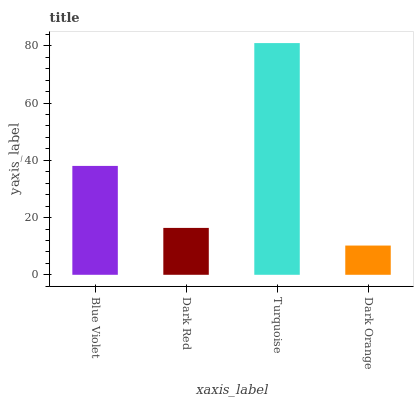Is Dark Orange the minimum?
Answer yes or no. Yes. Is Turquoise the maximum?
Answer yes or no. Yes. Is Dark Red the minimum?
Answer yes or no. No. Is Dark Red the maximum?
Answer yes or no. No. Is Blue Violet greater than Dark Red?
Answer yes or no. Yes. Is Dark Red less than Blue Violet?
Answer yes or no. Yes. Is Dark Red greater than Blue Violet?
Answer yes or no. No. Is Blue Violet less than Dark Red?
Answer yes or no. No. Is Blue Violet the high median?
Answer yes or no. Yes. Is Dark Red the low median?
Answer yes or no. Yes. Is Turquoise the high median?
Answer yes or no. No. Is Turquoise the low median?
Answer yes or no. No. 